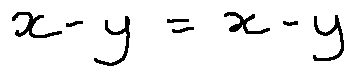Convert formula to latex. <formula><loc_0><loc_0><loc_500><loc_500>x - y = x - y</formula> 